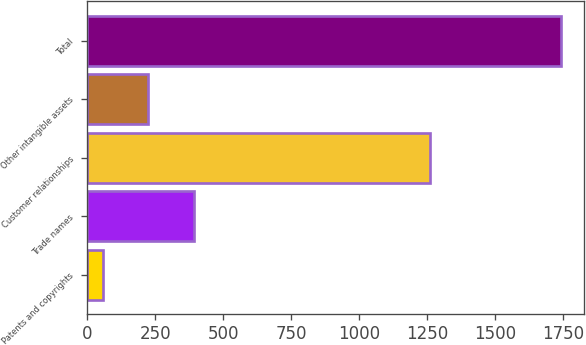Convert chart. <chart><loc_0><loc_0><loc_500><loc_500><bar_chart><fcel>Patents and copyrights<fcel>Trade names<fcel>Customer relationships<fcel>Other intangible assets<fcel>Total<nl><fcel>56.2<fcel>392.96<fcel>1259.7<fcel>224.58<fcel>1740<nl></chart> 